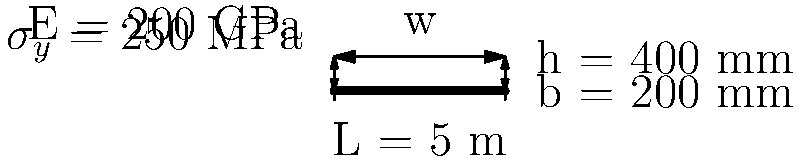A simply supported steel beam with a length of 5 m is subjected to a uniformly distributed load. The beam has a rectangular cross-section with a width of 200 mm and a height of 400 mm. Given that the elastic modulus (E) of steel is 200 GPa and its yield strength ($\sigma_{y}$) is 250 MPa, calculate the maximum uniformly distributed load (w) that the beam can safely support without yielding. Assume a factor of safety of 1.5. Let's approach this step-by-step:

1) First, we need to calculate the moment of inertia (I) of the beam:
   $I = \frac{bh^3}{12} = \frac{200 \times 400^3}{12} = 1.0667 \times 10^9$ mm⁴

2) The maximum bending moment (M) for a simply supported beam with uniformly distributed load is:
   $M = \frac{wL^2}{8}$

3) The maximum stress ($\sigma_{max}$) in the beam is given by:
   $\sigma_{max} = \frac{My}{I}$, where y is half the beam height (200 mm)

4) We want the maximum stress to be less than the yield strength divided by the factor of safety:
   $\sigma_{max} \leq \frac{\sigma_y}{FS} = \frac{250}{1.5} = 166.67$ MPa

5) Substituting and solving for w:
   $166.67 \times 10^6 = \frac{(w \times 5^2 \times 0.2)}{8 \times 1.0667 \times 10^{-3}}$

6) Solving for w:
   $w = \frac{166.67 \times 10^6 \times 8 \times 1.0667 \times 10^{-3}}{5^2 \times 0.2} = 71.11$ kN/m

Therefore, the maximum safe uniformly distributed load is approximately 71.11 kN/m.
Answer: 71.11 kN/m 